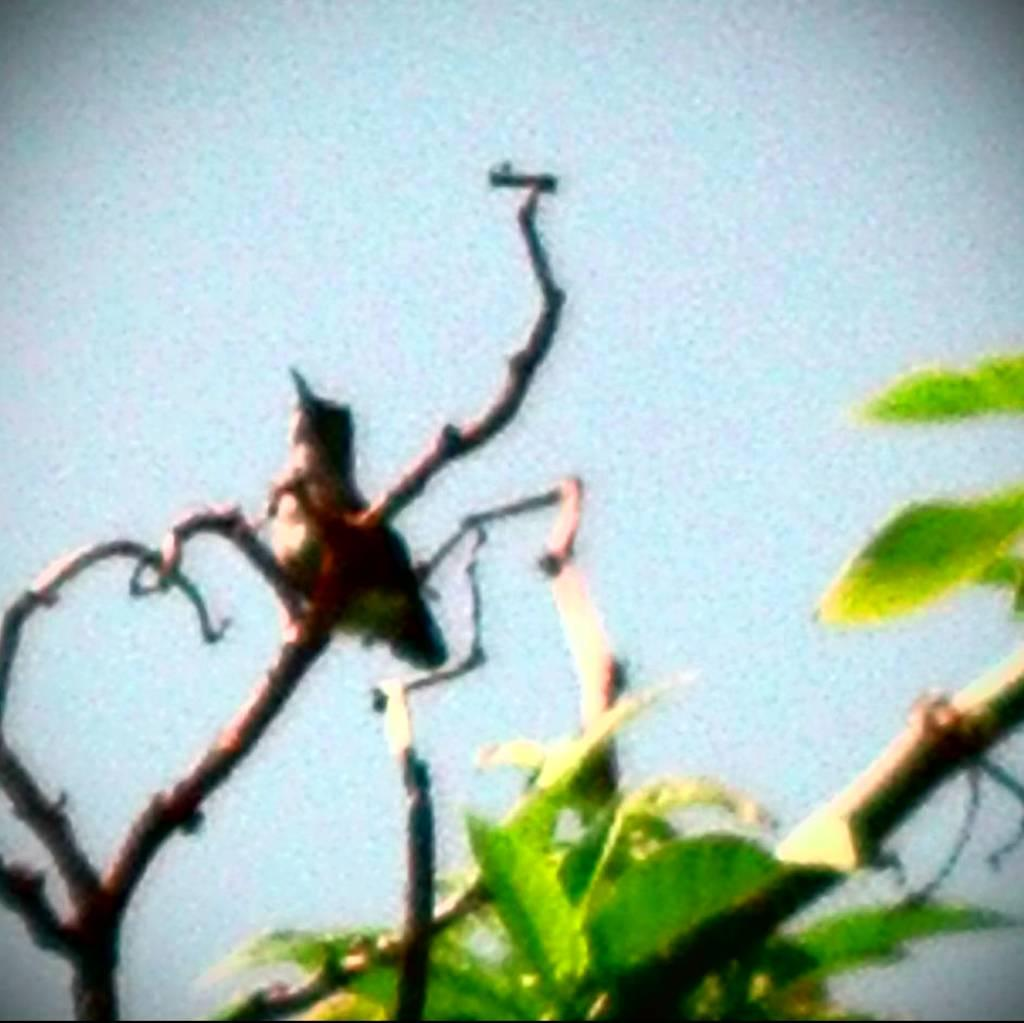What type of vegetation can be seen in the image? There are leaves in the image. Can you describe any living organisms present in the image? There is an insect on a stem in the image. What type of paste is being used by the chickens in the image? There are no chickens present in the image, so there is no paste being used. 